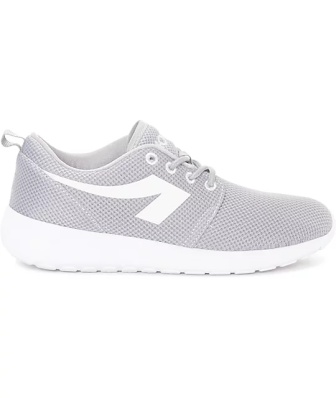Can you elaborate on the elements of the picture provided? The image features a modern sneaker with a minimalist design, exuding a sleek and sporty vibe. It is predominantly cast in shades of gray, with a crisp white sole and matching laces that weave neatly across the front. The side of the sneaker showcases a bold white stripe, possibly indicative of a brand or a design feature, that adds a touch of elegance to the shoe's overall appearance. The upper part of the sneaker is made of a breathable mesh material, ideal for athletic or casual wear, and the heel is equipped with a practical pull tab, suggesting ease of slipping on the shoe. The sneaker's orientation and the clean white background accentuate its design, making it the focal point of the image. It's a shoe that appears to harmonize comfort with style, likely appealing to fashion-forward consumers. 